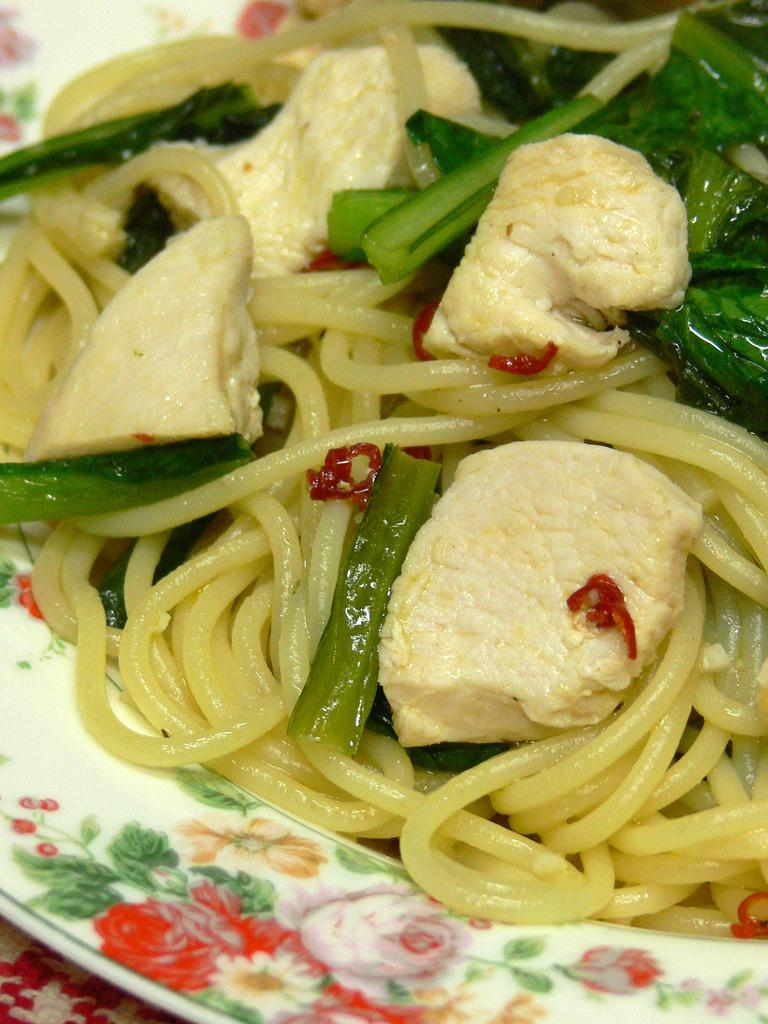What is on the plate that is visible in the image? There is food on the plate in the image. Where is the plate located in the image? The plate is on a platform in the image. Reasoning: Leting: Let's think step by step in order to produce the conversation. We start by identifying the main subject in the image, which is the plate with food. Then, we expand the conversation to include the location of the plate, which is on a platform. Each question is designed to elicit a specific detail about the image that is known from the provided facts. Absurd Question/Answer: How many brothers are shown in the image? There are no brothers present in the image; it only features a plate with food on a platform. What type of journey is depicted in the image? There is no journey depicted in the image; it only features a plate with food on a platform. 